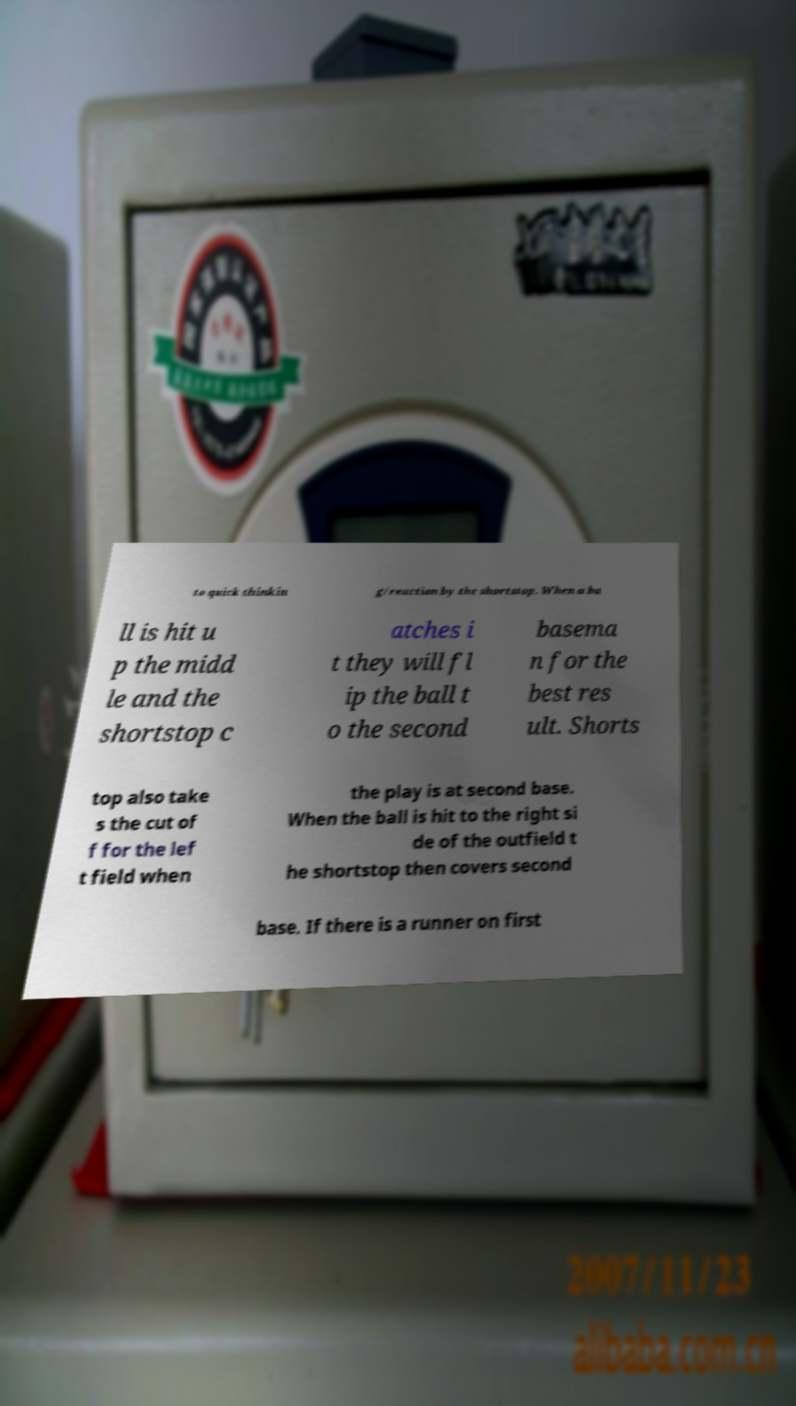Can you accurately transcribe the text from the provided image for me? to quick thinkin g/reaction by the shortstop. When a ba ll is hit u p the midd le and the shortstop c atches i t they will fl ip the ball t o the second basema n for the best res ult. Shorts top also take s the cut of f for the lef t field when the play is at second base. When the ball is hit to the right si de of the outfield t he shortstop then covers second base. If there is a runner on first 